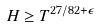Convert formula to latex. <formula><loc_0><loc_0><loc_500><loc_500>H \geq T ^ { 2 7 / 8 2 + \epsilon }</formula> 